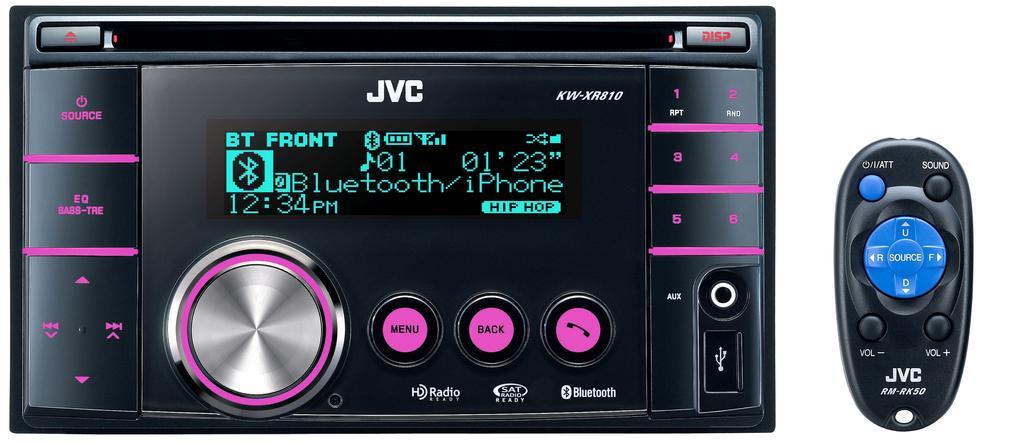In one or two sentences, can you explain what this image depicts? In this picture we can see the two electronic devices and we can see the text, numbers and some other pictures on the devices and we can see the buttons. The background of the image is white in color. 